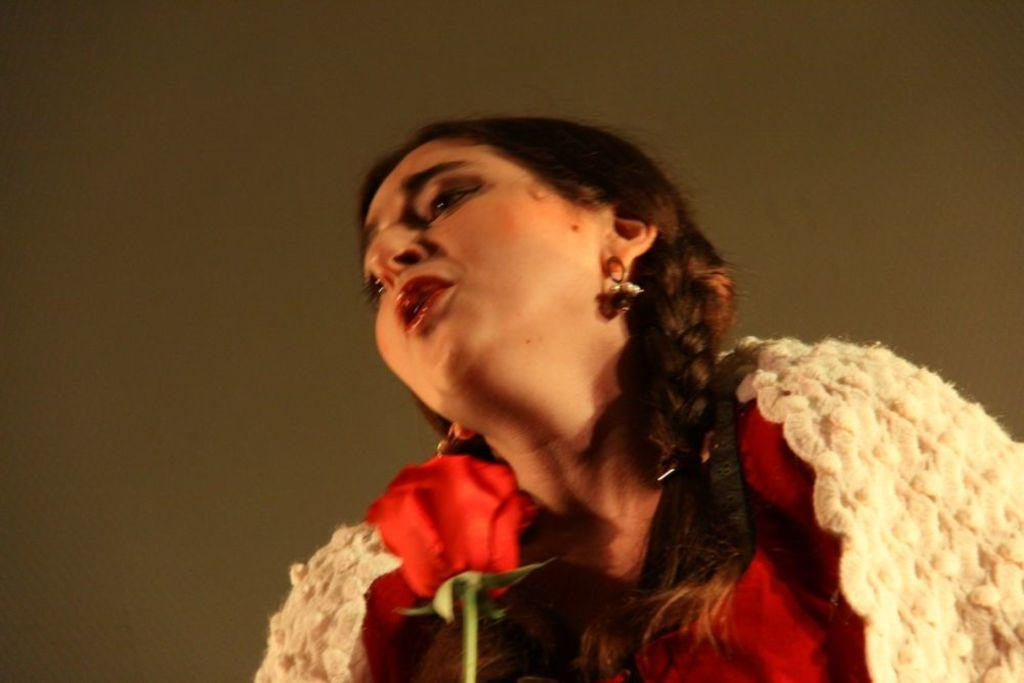Who is present in the image? There is a woman in the image. What object can be seen with the woman? There is a rose in the image. What country is the woman visiting in the image? The image does not provide any information about the country or location where the woman is. 